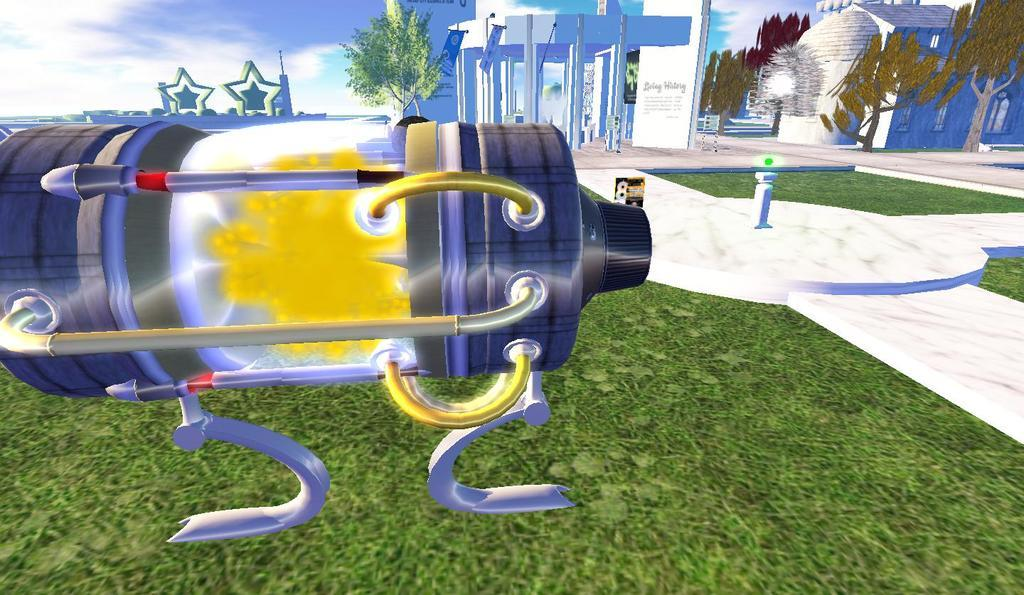What type of image is being described? The image is graphical. How many grains of wheat are visible in the image? There are no grains of wheat present in the image, as it is a graphical image. How many legs does the learning process have in the image? The image is graphical and does not depict a learning process or any legs. 